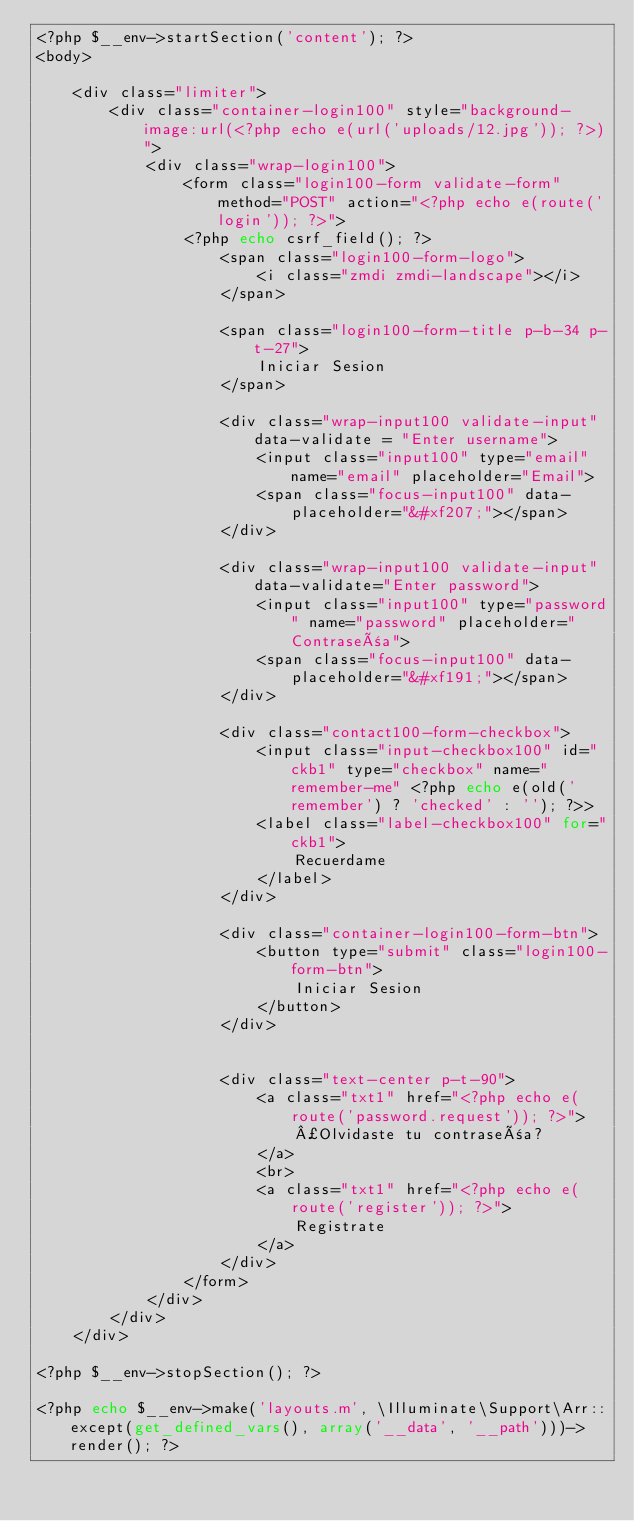<code> <loc_0><loc_0><loc_500><loc_500><_PHP_><?php $__env->startSection('content'); ?>
<body>
    
    <div class="limiter">
        <div class="container-login100" style="background-image:url(<?php echo e(url('uploads/12.jpg')); ?>)">
            <div class="wrap-login100">
                <form class="login100-form validate-form" method="POST" action="<?php echo e(route('login')); ?>">
                <?php echo csrf_field(); ?>
                    <span class="login100-form-logo">
                        <i class="zmdi zmdi-landscape"></i>
                    </span>

                    <span class="login100-form-title p-b-34 p-t-27">
                        Iniciar Sesion
                    </span>

                    <div class="wrap-input100 validate-input" data-validate = "Enter username">
                        <input class="input100" type="email" name="email" placeholder="Email">
                        <span class="focus-input100" data-placeholder="&#xf207;"></span>
                    </div>

                    <div class="wrap-input100 validate-input" data-validate="Enter password">
                        <input class="input100" type="password" name="password" placeholder="Contraseña">
                        <span class="focus-input100" data-placeholder="&#xf191;"></span>
                    </div>

                    <div class="contact100-form-checkbox">
                        <input class="input-checkbox100" id="ckb1" type="checkbox" name="remember-me" <?php echo e(old('remember') ? 'checked' : ''); ?>>
                        <label class="label-checkbox100" for="ckb1">
                            Recuerdame
                        </label>
                    </div>

                    <div class="container-login100-form-btn">
                        <button type="submit" class="login100-form-btn">
                            Iniciar Sesion
                        </button>
                    </div>


                    <div class="text-center p-t-90">
                        <a class="txt1" href="<?php echo e(route('password.request')); ?>">
                            ¿Olvidaste tu contraseña?
                        </a>
                        <br>
                        <a class="txt1" href="<?php echo e(route('register')); ?>">
                            Registrate
                        </a>
                    </div>
                </form>
            </div>
        </div>
    </div>
    
<?php $__env->stopSection(); ?>
    
<?php echo $__env->make('layouts.m', \Illuminate\Support\Arr::except(get_defined_vars(), array('__data', '__path')))->render(); ?></code> 